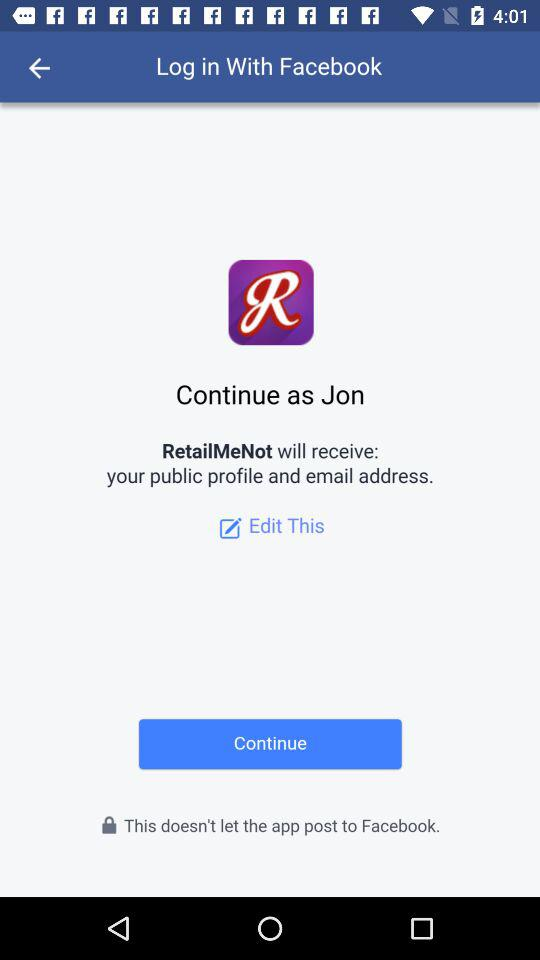With what application can the user log in? The user can log in with the application "Facebook". 